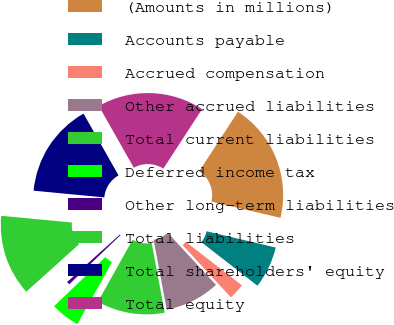<chart> <loc_0><loc_0><loc_500><loc_500><pie_chart><fcel>(Amounts in millions)<fcel>Accounts payable<fcel>Accrued compensation<fcel>Other accrued liabilities<fcel>Total current liabilities<fcel>Deferred income tax<fcel>Other long-term liabilities<fcel>Total liabilities<fcel>Total shareholders' equity<fcel>Total equity<nl><fcel>19.5%<fcel>6.83%<fcel>2.61%<fcel>8.94%<fcel>11.06%<fcel>4.72%<fcel>0.5%<fcel>13.17%<fcel>15.28%<fcel>17.39%<nl></chart> 